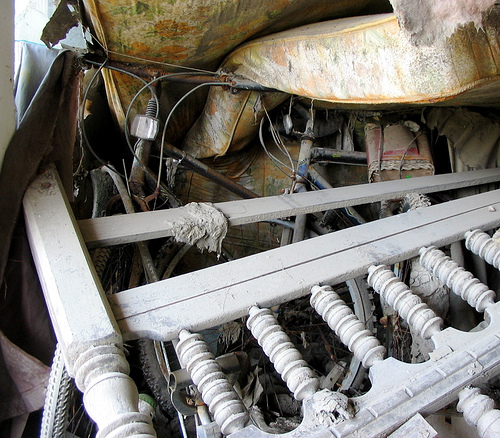<image>
Is the old mattress next to the wood pieces? Yes. The old mattress is positioned adjacent to the wood pieces, located nearby in the same general area. 